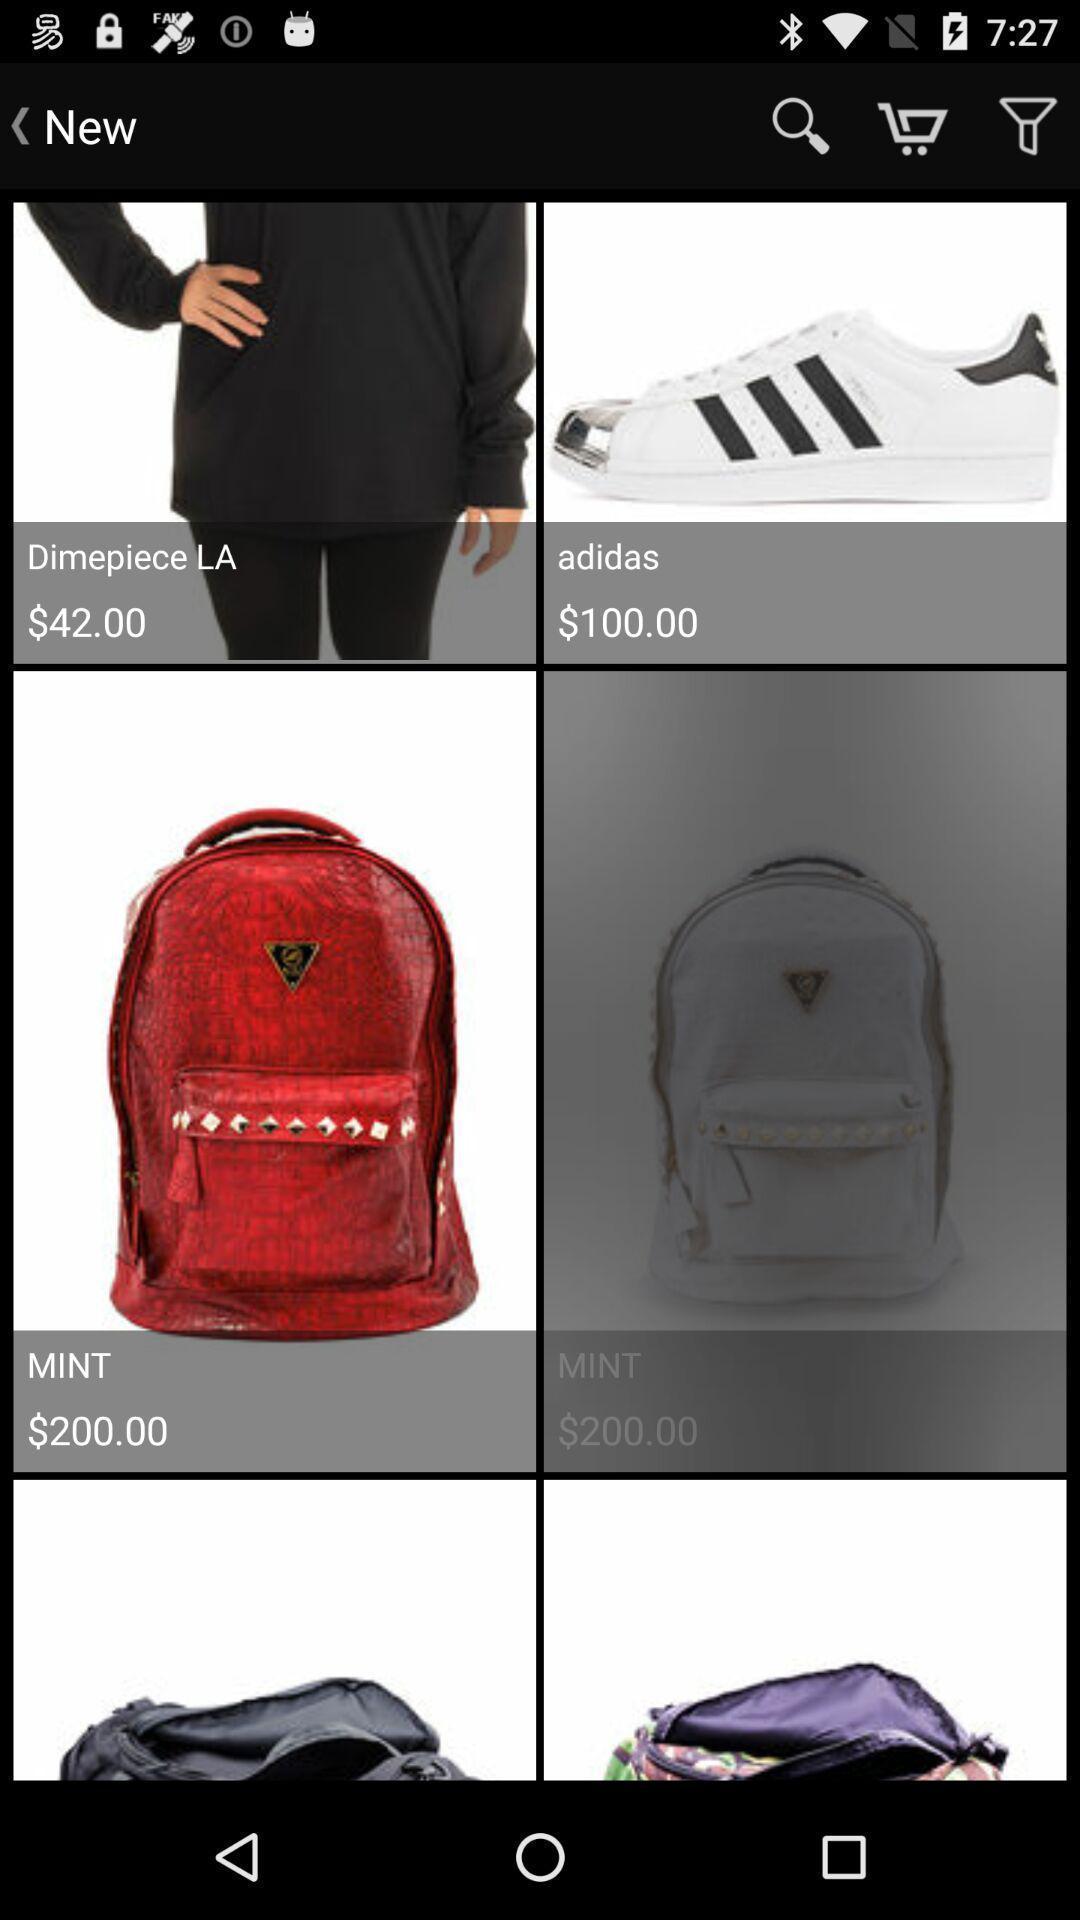What details can you identify in this image? Screen page of a shopping app. 